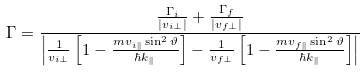Convert formula to latex. <formula><loc_0><loc_0><loc_500><loc_500>\Gamma = \frac { \frac { \Gamma _ { i } } { | v _ { i \perp } | } + \frac { \Gamma _ { f } } { | v _ { f \perp } | } } { \left | \frac { 1 } { v _ { i \perp } } \left [ 1 - \frac { m v _ { i \| } \sin ^ { 2 } \vartheta } { \hbar { k } _ { \| } } \right ] - \frac { 1 } { v _ { f \perp } } \left [ 1 - \frac { m v _ { f \| } \sin ^ { 2 } \vartheta } { \hbar { k } _ { \| } } \right ] \right | }</formula> 